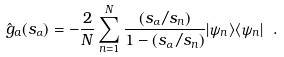Convert formula to latex. <formula><loc_0><loc_0><loc_500><loc_500>\hat { g } _ { a } ( s _ { \alpha } ) = - \frac { 2 } { N } \sum _ { n = 1 } ^ { N } \frac { ( s _ { \alpha } / s _ { n } ) } { 1 - ( s _ { \alpha } / s _ { n } ) } | \psi _ { n } \rangle \langle \psi _ { n } | \ .</formula> 